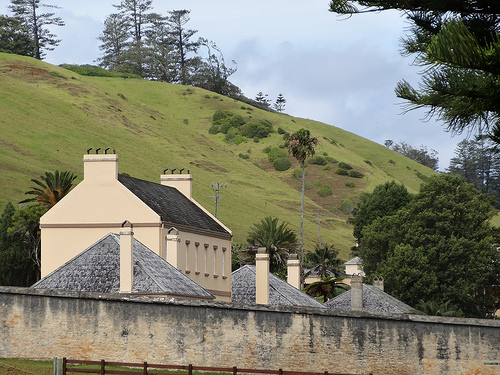<image>
Can you confirm if the tree is above the building? No. The tree is not positioned above the building. The vertical arrangement shows a different relationship. 